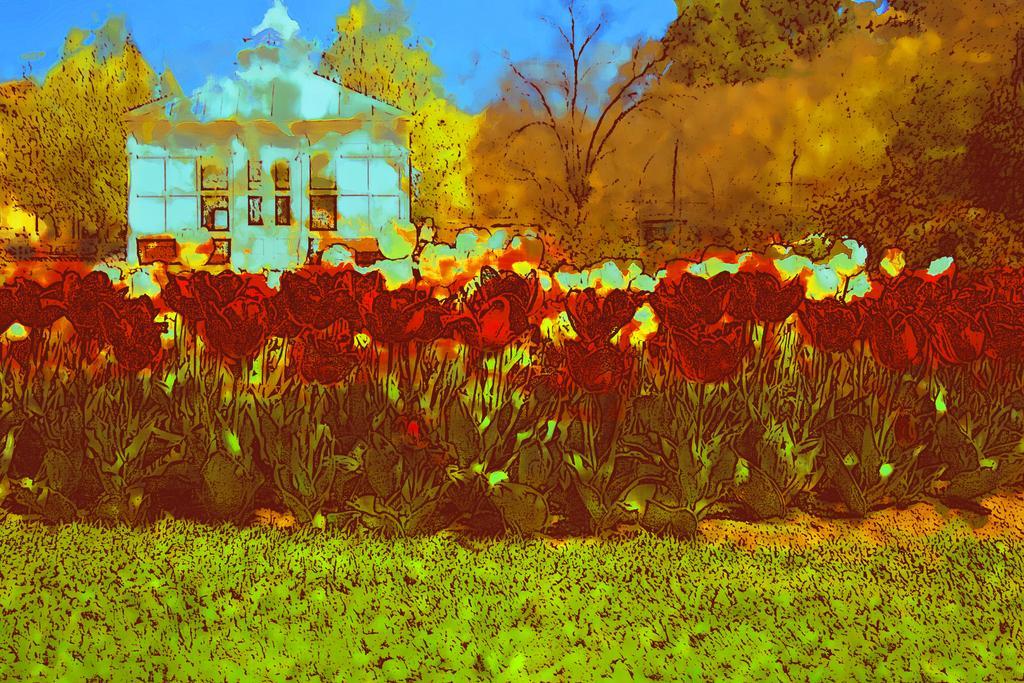In one or two sentences, can you explain what this image depicts? This is an edited image. In this image we can see a house with roof and windows. We can also see some plants with flowers, a group of trees and the sky. 